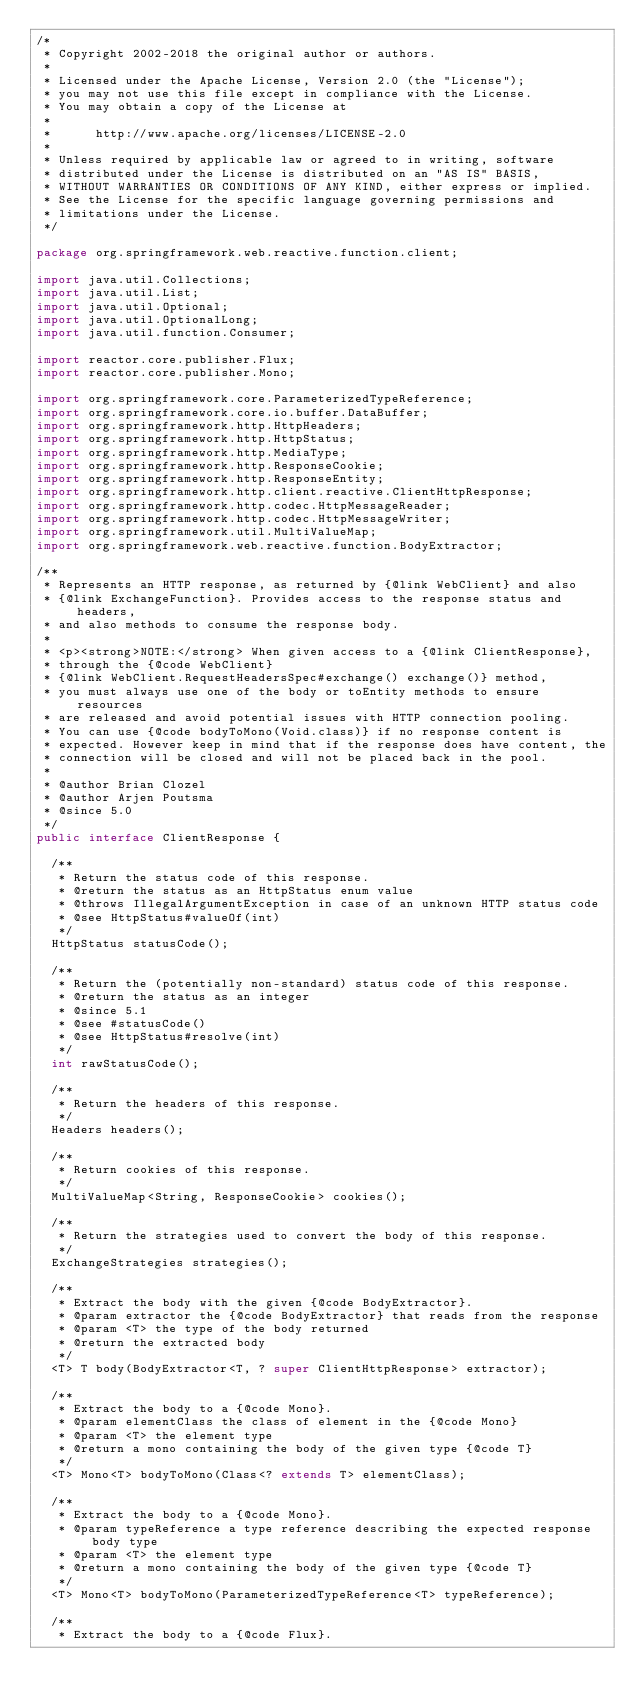<code> <loc_0><loc_0><loc_500><loc_500><_Java_>/*
 * Copyright 2002-2018 the original author or authors.
 *
 * Licensed under the Apache License, Version 2.0 (the "License");
 * you may not use this file except in compliance with the License.
 * You may obtain a copy of the License at
 *
 *      http://www.apache.org/licenses/LICENSE-2.0
 *
 * Unless required by applicable law or agreed to in writing, software
 * distributed under the License is distributed on an "AS IS" BASIS,
 * WITHOUT WARRANTIES OR CONDITIONS OF ANY KIND, either express or implied.
 * See the License for the specific language governing permissions and
 * limitations under the License.
 */

package org.springframework.web.reactive.function.client;

import java.util.Collections;
import java.util.List;
import java.util.Optional;
import java.util.OptionalLong;
import java.util.function.Consumer;

import reactor.core.publisher.Flux;
import reactor.core.publisher.Mono;

import org.springframework.core.ParameterizedTypeReference;
import org.springframework.core.io.buffer.DataBuffer;
import org.springframework.http.HttpHeaders;
import org.springframework.http.HttpStatus;
import org.springframework.http.MediaType;
import org.springframework.http.ResponseCookie;
import org.springframework.http.ResponseEntity;
import org.springframework.http.client.reactive.ClientHttpResponse;
import org.springframework.http.codec.HttpMessageReader;
import org.springframework.http.codec.HttpMessageWriter;
import org.springframework.util.MultiValueMap;
import org.springframework.web.reactive.function.BodyExtractor;

/**
 * Represents an HTTP response, as returned by {@link WebClient} and also
 * {@link ExchangeFunction}. Provides access to the response status and headers,
 * and also methods to consume the response body.
 *
 * <p><strong>NOTE:</strong> When given access to a {@link ClientResponse},
 * through the {@code WebClient}
 * {@link WebClient.RequestHeadersSpec#exchange() exchange()} method,
 * you must always use one of the body or toEntity methods to ensure resources
 * are released and avoid potential issues with HTTP connection pooling.
 * You can use {@code bodyToMono(Void.class)} if no response content is
 * expected. However keep in mind that if the response does have content, the
 * connection will be closed and will not be placed back in the pool.
 *
 * @author Brian Clozel
 * @author Arjen Poutsma
 * @since 5.0
 */
public interface ClientResponse {

	/**
	 * Return the status code of this response.
	 * @return the status as an HttpStatus enum value
	 * @throws IllegalArgumentException in case of an unknown HTTP status code
	 * @see HttpStatus#valueOf(int)
	 */
	HttpStatus statusCode();

	/**
	 * Return the (potentially non-standard) status code of this response.
	 * @return the status as an integer
	 * @since 5.1
	 * @see #statusCode()
	 * @see HttpStatus#resolve(int)
	 */
	int rawStatusCode();

	/**
	 * Return the headers of this response.
	 */
	Headers headers();

	/**
	 * Return cookies of this response.
	 */
	MultiValueMap<String, ResponseCookie> cookies();

	/**
	 * Return the strategies used to convert the body of this response.
	 */
	ExchangeStrategies strategies();

	/**
	 * Extract the body with the given {@code BodyExtractor}.
	 * @param extractor the {@code BodyExtractor} that reads from the response
	 * @param <T> the type of the body returned
	 * @return the extracted body
	 */
	<T> T body(BodyExtractor<T, ? super ClientHttpResponse> extractor);

	/**
	 * Extract the body to a {@code Mono}.
	 * @param elementClass the class of element in the {@code Mono}
	 * @param <T> the element type
	 * @return a mono containing the body of the given type {@code T}
	 */
	<T> Mono<T> bodyToMono(Class<? extends T> elementClass);

	/**
	 * Extract the body to a {@code Mono}.
	 * @param typeReference a type reference describing the expected response body type
	 * @param <T> the element type
	 * @return a mono containing the body of the given type {@code T}
	 */
	<T> Mono<T> bodyToMono(ParameterizedTypeReference<T> typeReference);

	/**
	 * Extract the body to a {@code Flux}.</code> 